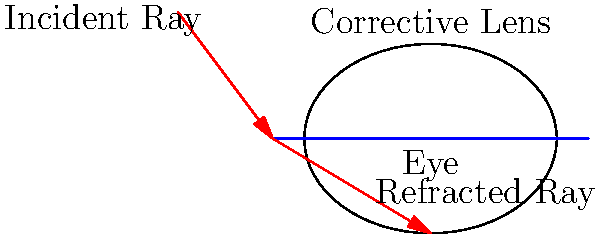A concave lens is used to correct farsightedness (hyperopia). If the focal length of the lens is 20 cm and an object is placed 30 cm from the lens, at what distance from the lens will the image be formed? Use the thin lens equation: $\frac{1}{f} = \frac{1}{d_o} + \frac{1}{d_i}$, where $f$ is the focal length, $d_o$ is the object distance, and $d_i$ is the image distance. Let's approach this step-by-step:

1) We are given:
   Focal length, $f = 20$ cm
   Object distance, $d_o = 30$ cm
   We need to find the image distance, $d_i$

2) We'll use the thin lens equation: $\frac{1}{f} = \frac{1}{d_o} + \frac{1}{d_i}$

3) Let's substitute the known values:
   $\frac{1}{20} = \frac{1}{30} + \frac{1}{d_i}$

4) Now, let's solve for $\frac{1}{d_i}$:
   $\frac{1}{d_i} = \frac{1}{20} - \frac{1}{30}$

5) Finding a common denominator:
   $\frac{1}{d_i} = \frac{3}{60} - \frac{2}{60} = \frac{1}{60}$

6) Now, we can find $d_i$:
   $d_i = 60$ cm

7) However, for a concave lens, the image is always virtual and on the same side as the object. This is represented by a negative image distance.

Therefore, the final answer is $d_i = -60$ cm.
Answer: $-60$ cm 